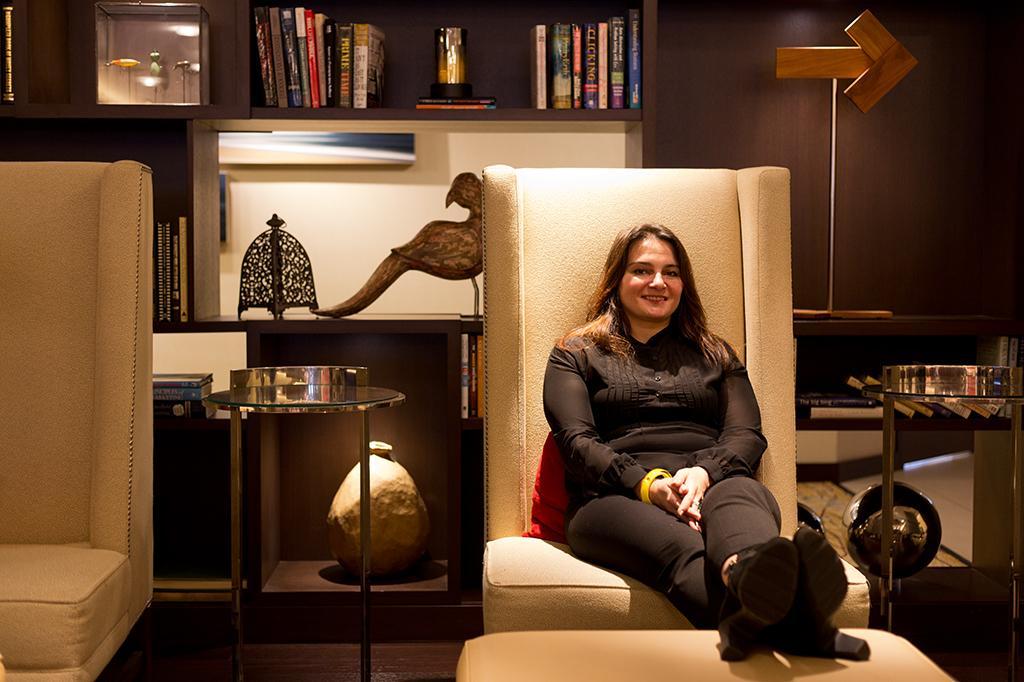Can you describe this image briefly? In this image, we can see a person wearing clothes and sitting on the chair. There is a rack in the middle of the image contains some books. There is a table at the bottom of the image. There is an another chair on the left side of the image. 